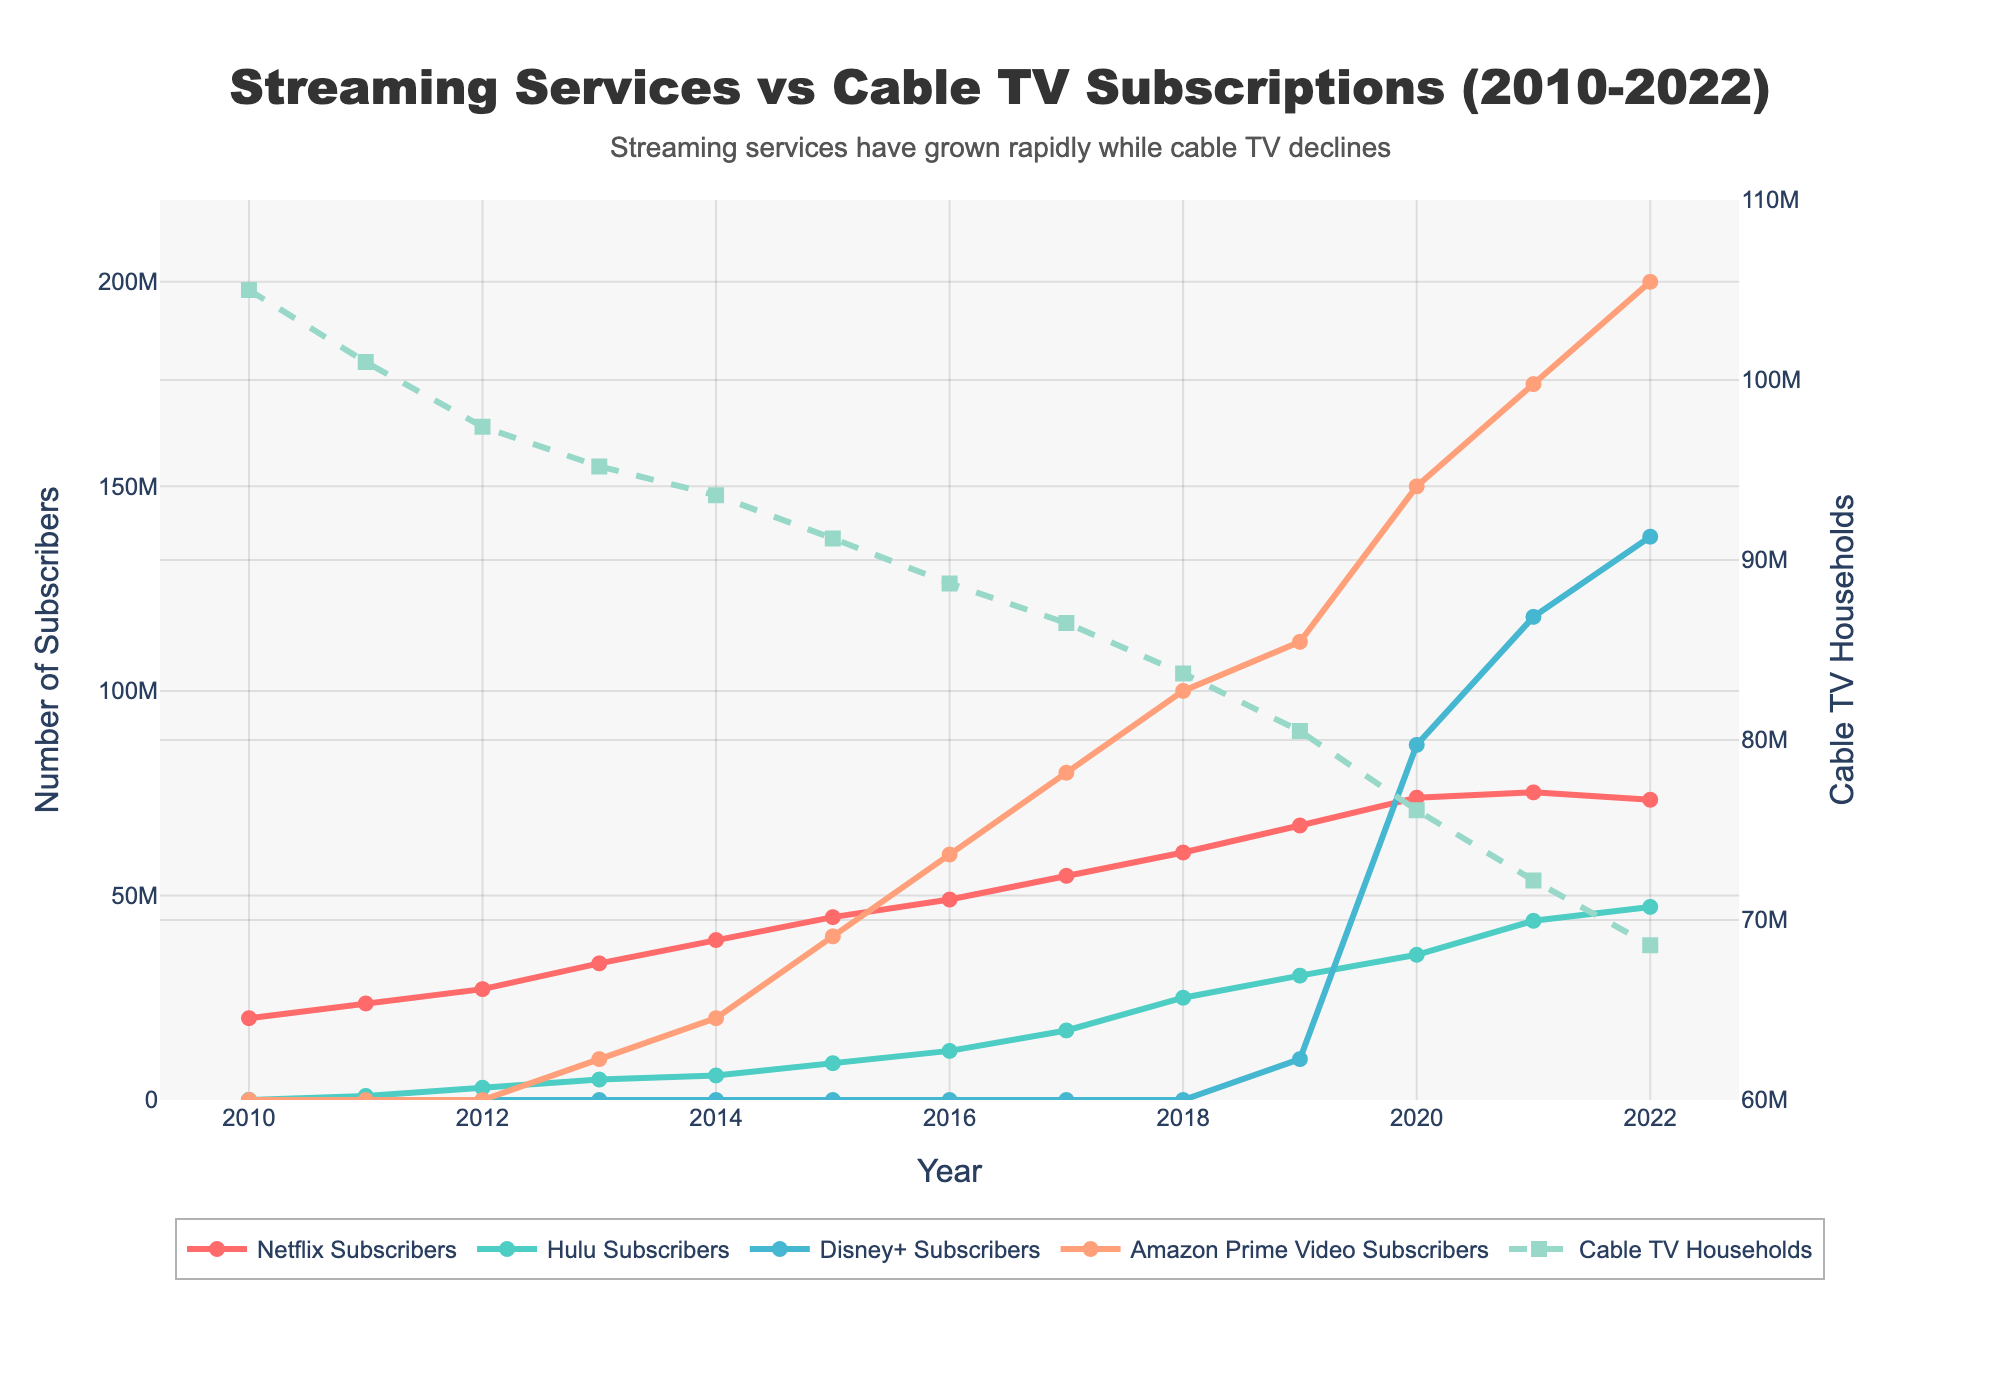what are the trends in Netflix and Cable TV subscriptions over the years? By observing the lines, we see that Netflix subscriptions (red line) rise continuously from 2010 to 2021 and then slightly decline in 2022. In contrast, Cable TV households (dashed green line) show a steady decline from 2010 to 2022.
Answer: Netflix subscriptions increase, Cable TV households decrease What is the difference in the number of Amazon Prime Video Subscribers between 2013 and 2022? In 2013, Amazon Prime Video Subscribers were 10,000,000, and in 2022, they were 200,000,000. The difference is 200,000,000 - 10,000,000 = 190,000,000.
Answer: 190,000,000 Which streaming service had the highest number of subscribers in 2022? By comparing the endpoints of the lines for each streaming service in 2022, Disney+ (blue line) shows the highest number of subscribers with 137,700,000.
Answer: Disney+ How did Hulu's growth trend compare to Netflix's growth trend? Both lines for Hulu (green line) and Netflix (red line) generally trend upwards, but Hulu shows a more gradual increase, especially after 2017, while Netflix's growth is more rapid until 2020, followed by a slight decline.
Answer: Hulu's growth is more gradual, Netflix's growth is more rapid until 2020 What was the combined number of Disney+ and Amazon Prime Video subscribers in 2021? Disney+ had 118,100,000 subscribers, and Amazon Prime Video had 175,000,000 subscribers in 2021. Combined, they have 118,100,000 + 175,000,000 = 293,100,000.
Answer: 293,100,000 Which service showed the most rapid growth between 2019 and 2020? By observing the slopes of the lines between 2019 and 2020, Disney+ (blue line) shows the most significant increase, going from 10,000,000 to 86,800,000, a difference of 76,800,000.
Answer: Disney+ In which year did Netflix surpass 50,000,000 subscribers? By following the red line and the corresponding year markers, Netflix surpassed 50,000,000 subscribers in 2017.
Answer: 2017 What has been the trend for Hulu subscribers since 2010? The green line representing Hulu subscribers starts at almost zero in 2010 and shows a steady upward trend across all years, reaching 47,200,000 subscribers in 2022.
Answer: Steady upward trend By how much did the number of Cable TV households decrease from 2010 to 2022? The number of Cable TV households declined from 105,000,000 in 2010 to 68,600,000 in 2022. The decrease is 105,000,000 - 68,600,000 = 36,400,000.
Answer: 36,400,000 Which streaming service reached 100,000,000 subscribers first, and in which year? Disney+ first reached over 100,000,000 subscribers in 2020, as observed by the blue line crossing the 100,000,000 mark in that year.
Answer: Disney+, 2020 